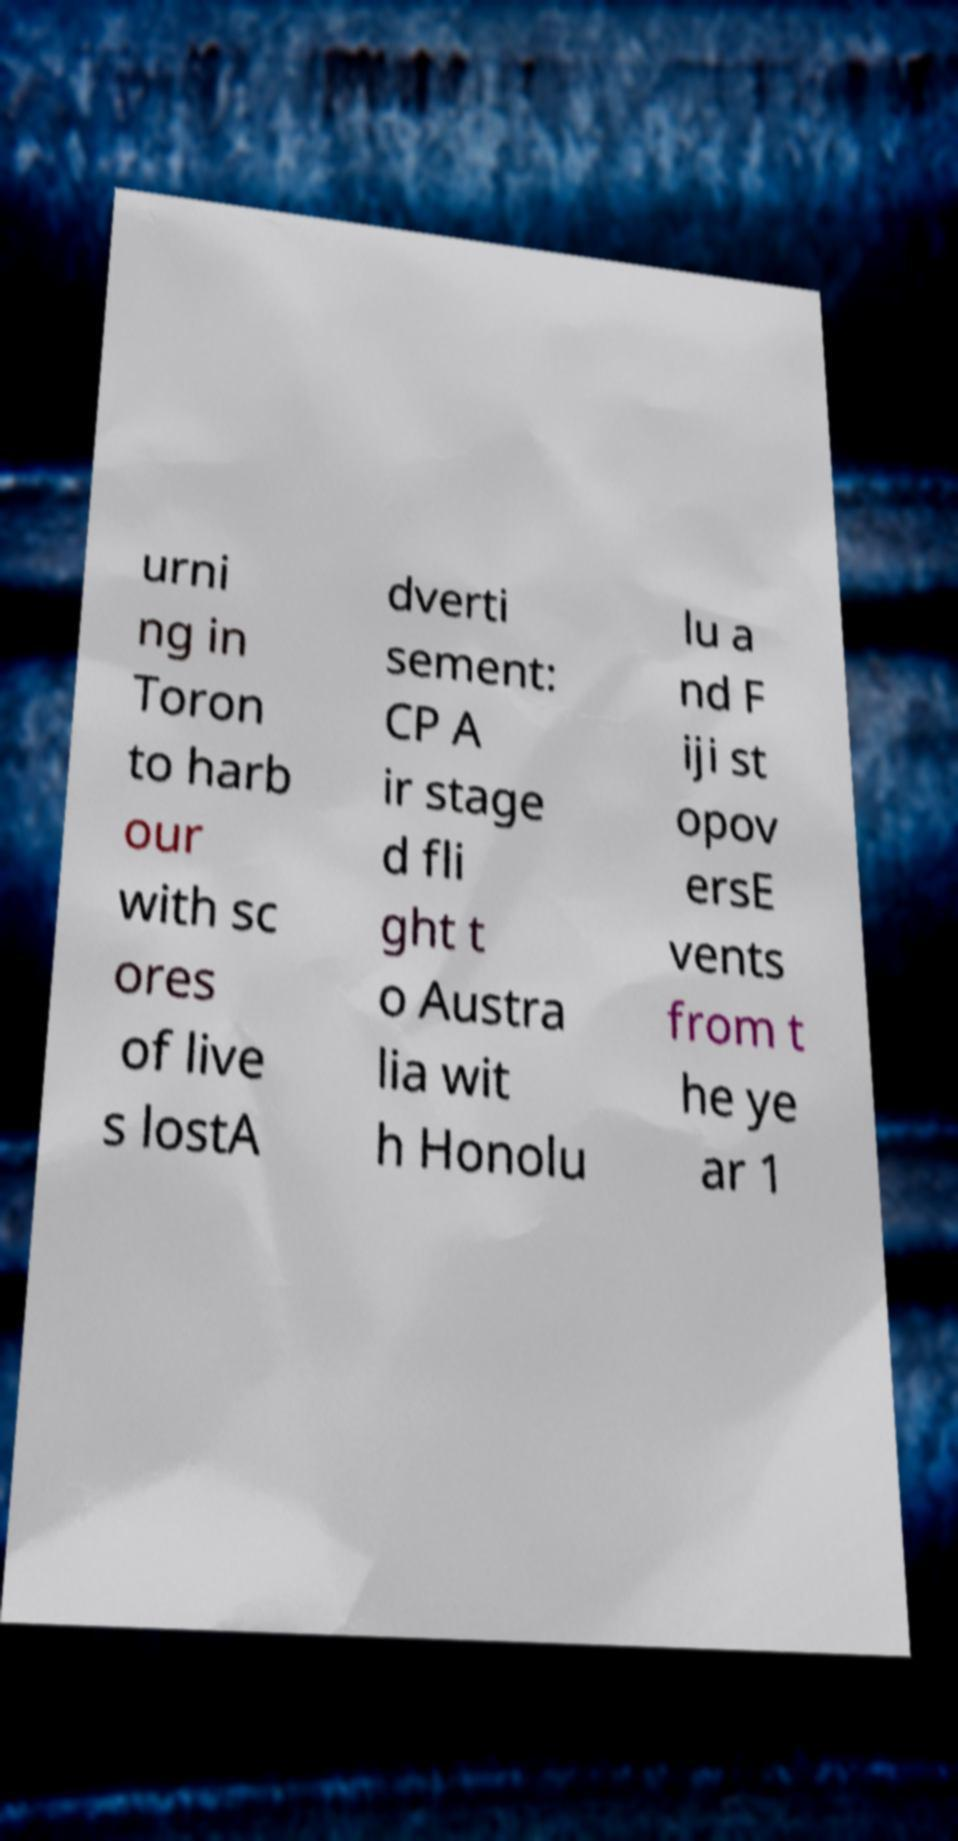For documentation purposes, I need the text within this image transcribed. Could you provide that? urni ng in Toron to harb our with sc ores of live s lostA dverti sement: CP A ir stage d fli ght t o Austra lia wit h Honolu lu a nd F iji st opov ersE vents from t he ye ar 1 